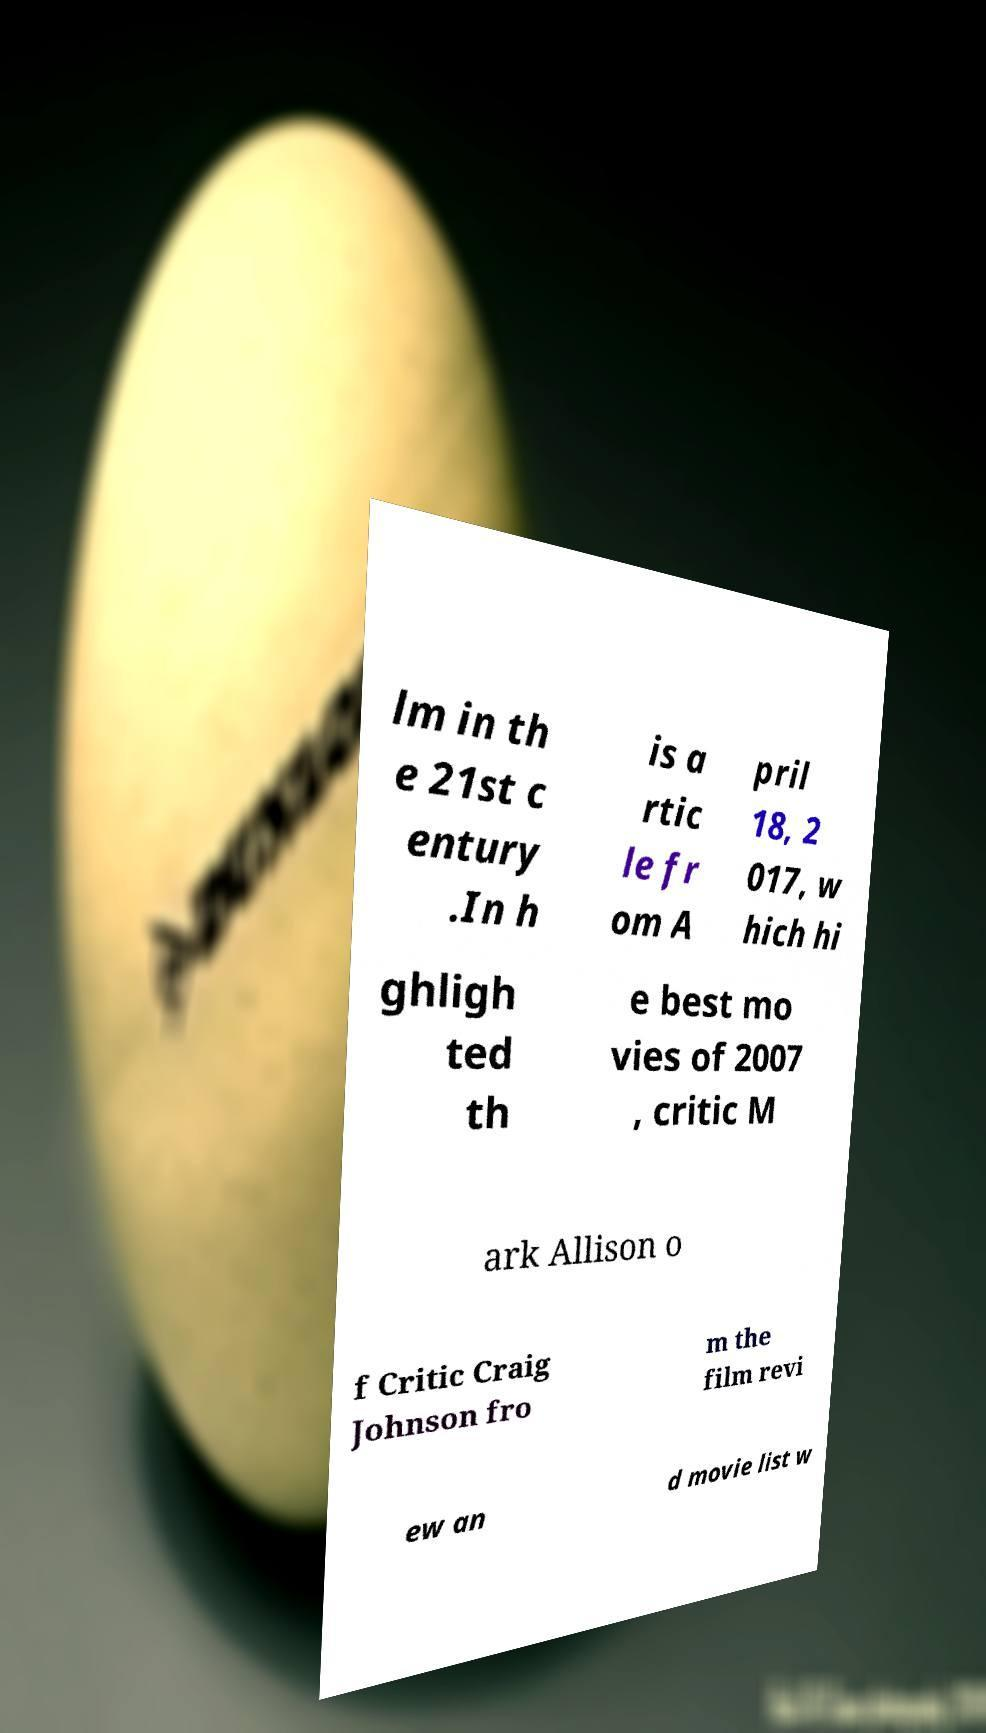Could you extract and type out the text from this image? lm in th e 21st c entury .In h is a rtic le fr om A pril 18, 2 017, w hich hi ghligh ted th e best mo vies of 2007 , critic M ark Allison o f Critic Craig Johnson fro m the film revi ew an d movie list w 